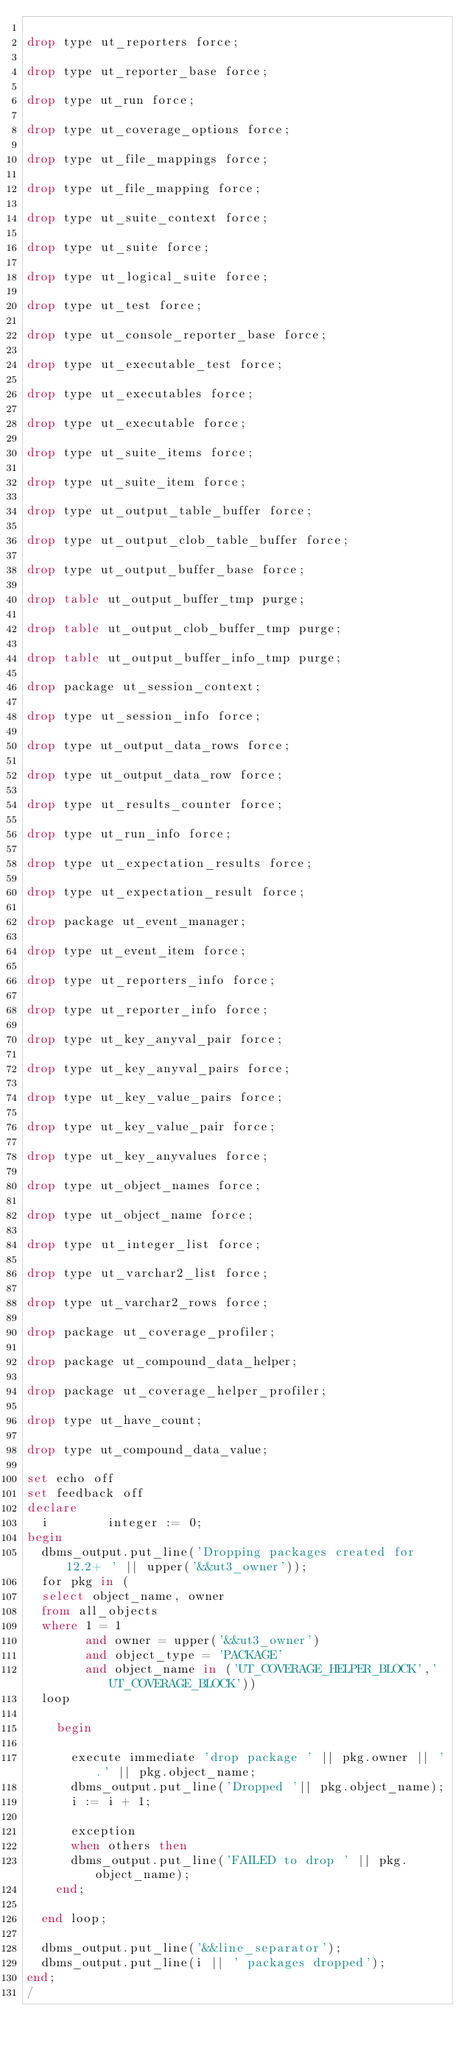Convert code to text. <code><loc_0><loc_0><loc_500><loc_500><_SQL_>
drop type ut_reporters force;

drop type ut_reporter_base force;

drop type ut_run force;

drop type ut_coverage_options force;

drop type ut_file_mappings force;

drop type ut_file_mapping force;

drop type ut_suite_context force;

drop type ut_suite force;

drop type ut_logical_suite force;

drop type ut_test force;

drop type ut_console_reporter_base force;

drop type ut_executable_test force;

drop type ut_executables force;

drop type ut_executable force;

drop type ut_suite_items force;

drop type ut_suite_item force;

drop type ut_output_table_buffer force;

drop type ut_output_clob_table_buffer force;

drop type ut_output_buffer_base force;

drop table ut_output_buffer_tmp purge;

drop table ut_output_clob_buffer_tmp purge;

drop table ut_output_buffer_info_tmp purge;

drop package ut_session_context;

drop type ut_session_info force;

drop type ut_output_data_rows force;

drop type ut_output_data_row force;

drop type ut_results_counter force;

drop type ut_run_info force;

drop type ut_expectation_results force;

drop type ut_expectation_result force;

drop package ut_event_manager;

drop type ut_event_item force;

drop type ut_reporters_info force;

drop type ut_reporter_info force;

drop type ut_key_anyval_pair force;

drop type ut_key_anyval_pairs force;

drop type ut_key_value_pairs force;

drop type ut_key_value_pair force;

drop type ut_key_anyvalues force;

drop type ut_object_names force;

drop type ut_object_name force;

drop type ut_integer_list force;

drop type ut_varchar2_list force;

drop type ut_varchar2_rows force;

drop package ut_coverage_profiler;

drop package ut_compound_data_helper;

drop package ut_coverage_helper_profiler;

drop type ut_have_count;

drop type ut_compound_data_value;

set echo off
set feedback off
declare
  i        integer := 0;
begin
  dbms_output.put_line('Dropping packages created for 12.2+ ' || upper('&&ut3_owner'));
  for pkg in (
  select object_name, owner
  from all_objects
  where 1 = 1
        and owner = upper('&&ut3_owner')
        and object_type = 'PACKAGE'
        and object_name in ('UT_COVERAGE_HELPER_BLOCK','UT_COVERAGE_BLOCK'))
  loop

    begin

      execute immediate 'drop package ' || pkg.owner || '.' || pkg.object_name;
      dbms_output.put_line('Dropped '|| pkg.object_name);
      i := i + 1;

      exception
      when others then
      dbms_output.put_line('FAILED to drop ' || pkg.object_name);
    end;

  end loop;

  dbms_output.put_line('&&line_separator');
  dbms_output.put_line(i || ' packages dropped');
end;
/
</code> 